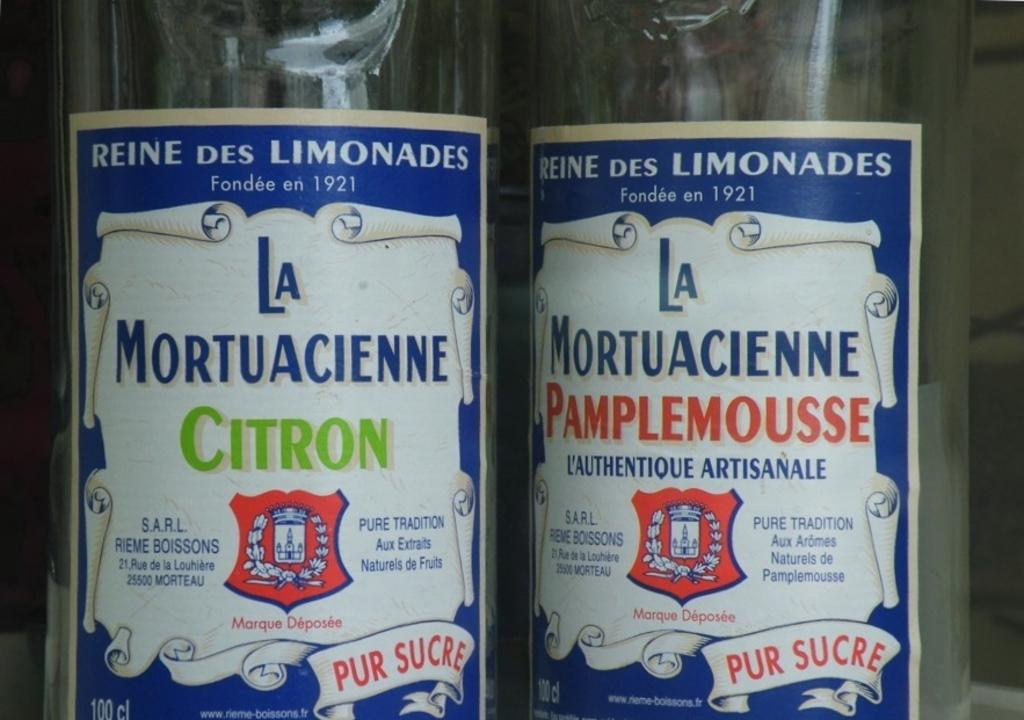How many bottles can be seen in the image? There are two bottles in the image. What distinguishing feature do the bottles have? The bottles have labels on them. What historical event is depicted on the wax sculpture in the image? There is no wax sculpture or historical event mentioned in the provided facts, so this question cannot be answered. 